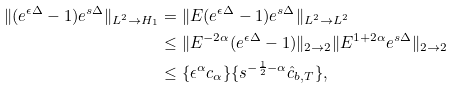<formula> <loc_0><loc_0><loc_500><loc_500>\| ( e ^ { \epsilon \Delta } - 1 ) e ^ { s \Delta } \| _ { L ^ { 2 } \rightarrow H _ { 1 } } & = \| E ( e ^ { \epsilon \Delta } - 1 ) e ^ { s \Delta } \| _ { L ^ { 2 } \rightarrow L ^ { 2 } } \\ & \leq \| E ^ { - 2 \alpha } ( e ^ { \epsilon \Delta } - 1 ) \| _ { 2 \rightarrow 2 } \| E ^ { 1 + 2 \alpha } e ^ { s \Delta } \| _ { 2 \rightarrow 2 } \\ & \leq \{ \epsilon ^ { \alpha } c _ { \alpha } \} \{ s ^ { - \frac { 1 } { 2 } - \alpha } \hat { c } _ { b , T } \} ,</formula> 